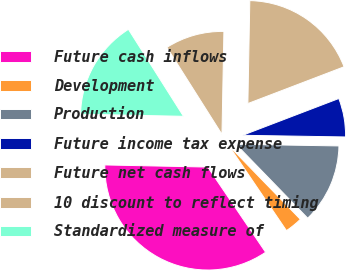Convert chart to OTSL. <chart><loc_0><loc_0><loc_500><loc_500><pie_chart><fcel>Future cash inflows<fcel>Development<fcel>Production<fcel>Future income tax expense<fcel>Future net cash flows<fcel>10 discount to reflect timing<fcel>Standardized measure of<nl><fcel>34.82%<fcel>2.77%<fcel>12.48%<fcel>6.07%<fcel>18.89%<fcel>9.28%<fcel>15.69%<nl></chart> 